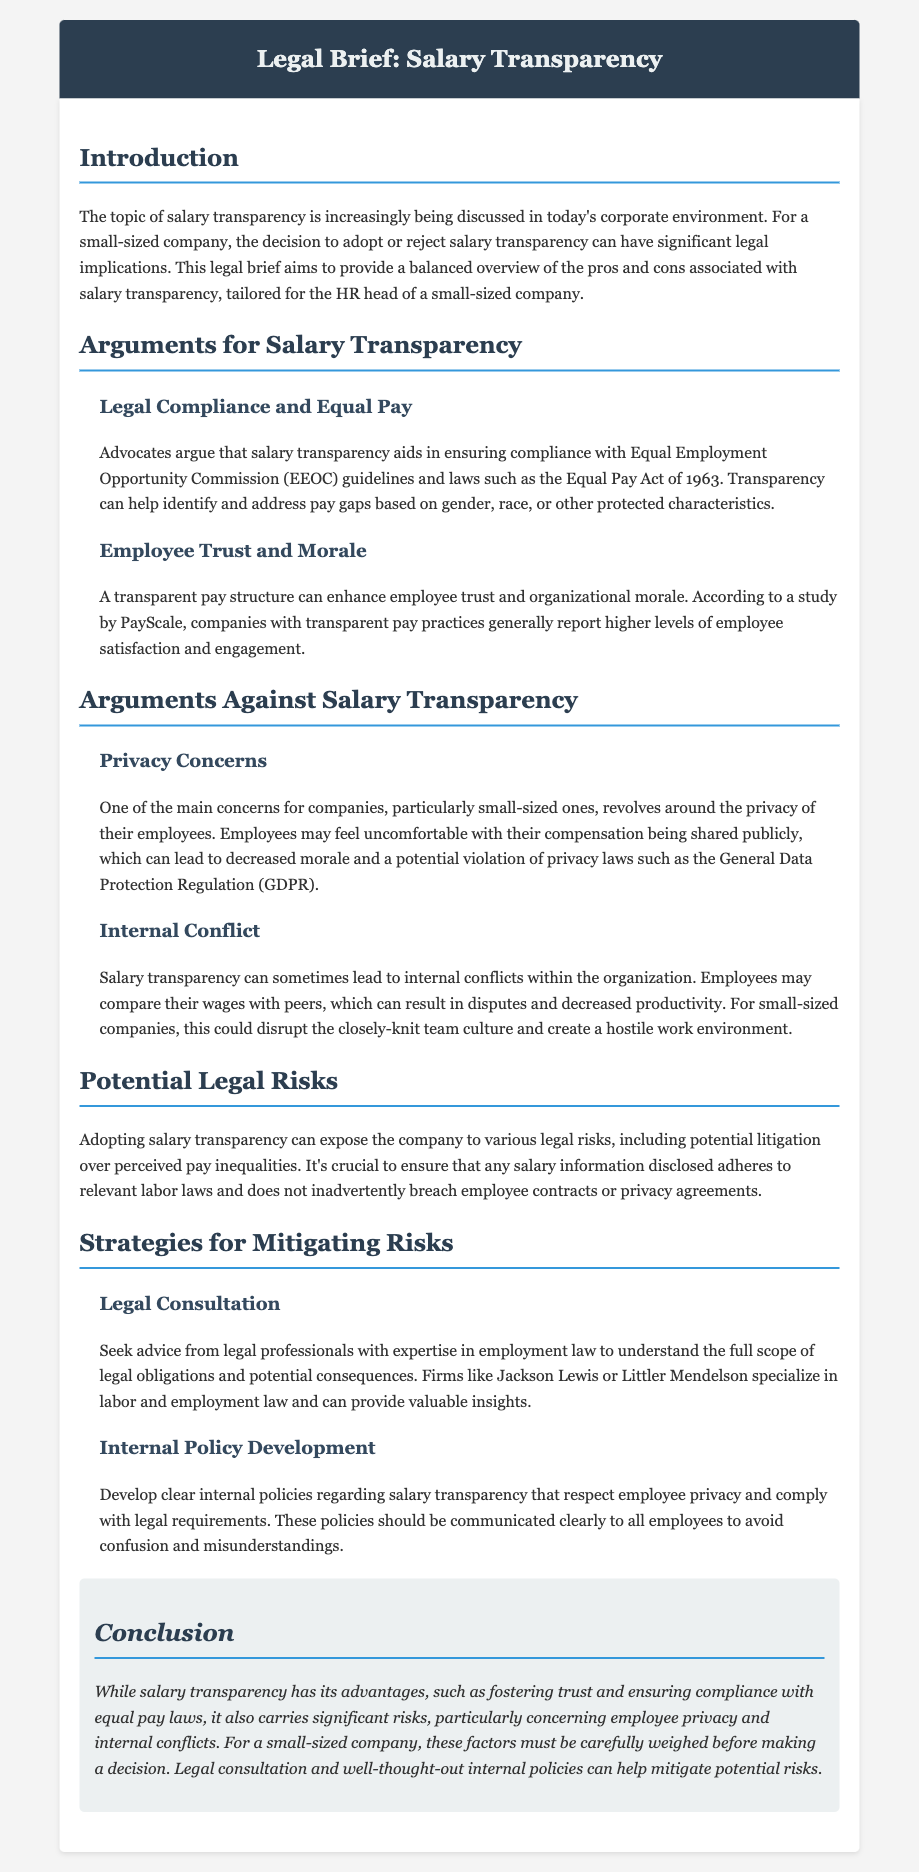what is the title of the document? The title of the document is located at the top of the header section.
Answer: Legal Brief: Salary Transparency who is the target audience for this legal brief? The target audience is specified in the introduction of the document.
Answer: HR head of a small-sized company what year was the Equal Pay Act enacted? The year of enactment is detailed in the arguments for salary transparency section.
Answer: 1963 what is one argument for salary transparency mentioned in the document? The document lists arguments for and against salary transparency, one being in the topics covered in the relevant section.
Answer: Legal Compliance and Equal Pay what is the main concern regarding privacy highlighted in the document? The main concern is discussed under the arguments against salary transparency section, specifically regarding employee feelings about their compensation.
Answer: Privacy Concerns which organizations are suggested for legal consultation? The document specifically mentions firms for legal advice in the strategies section.
Answer: Jackson Lewis or Littler Mendelson what is one strategy for mitigating risks associated with salary transparency? Strategies are outlined in the relevant section of the document.
Answer: Internal Policy Development how does salary transparency potentially affect company culture? The effect on culture is discussed in the arguments against salary transparency section.
Answer: Internal Conflict 